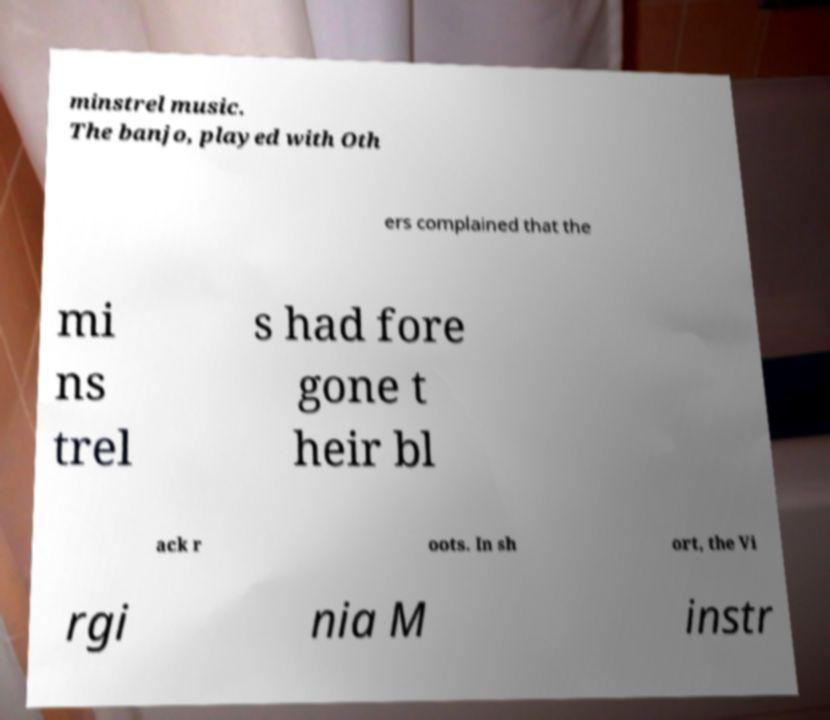Can you read and provide the text displayed in the image?This photo seems to have some interesting text. Can you extract and type it out for me? minstrel music. The banjo, played with Oth ers complained that the mi ns trel s had fore gone t heir bl ack r oots. In sh ort, the Vi rgi nia M instr 